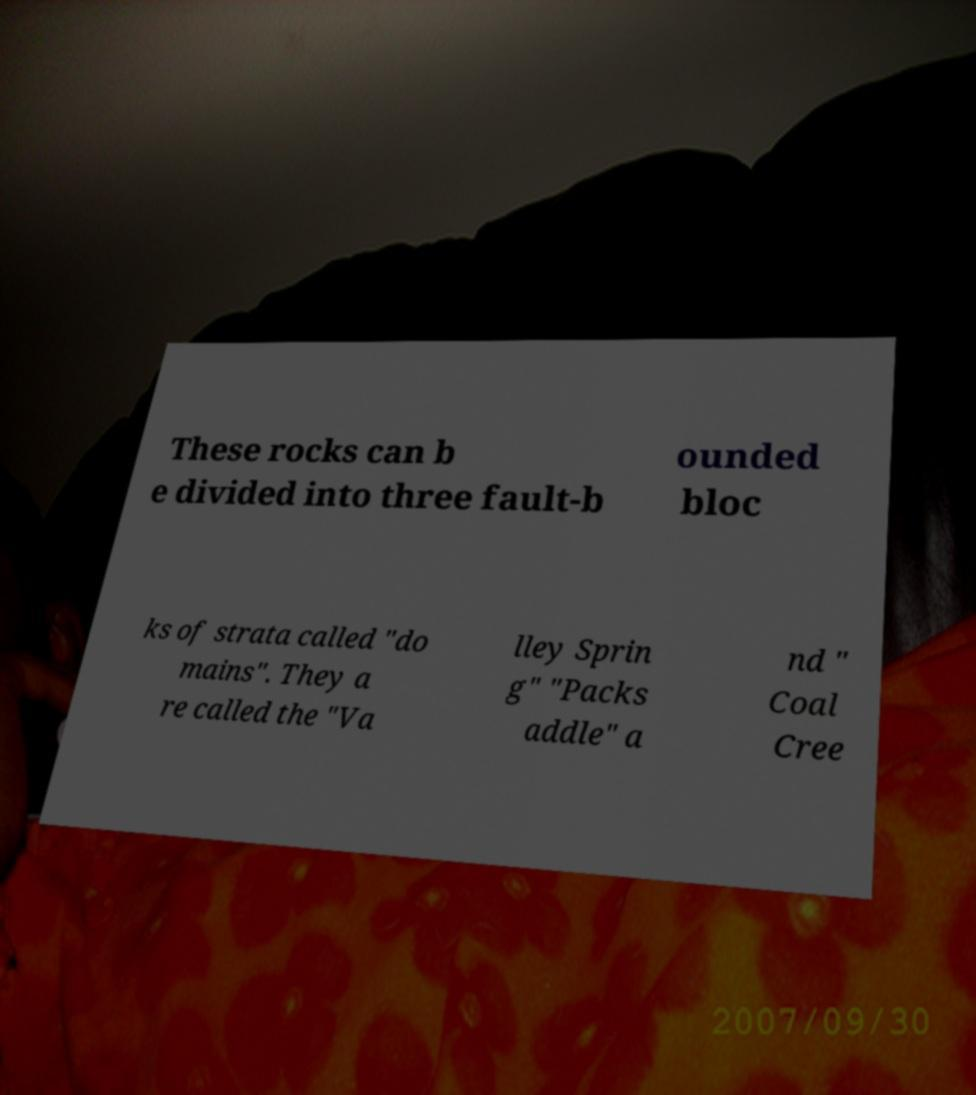Please identify and transcribe the text found in this image. These rocks can b e divided into three fault-b ounded bloc ks of strata called "do mains". They a re called the "Va lley Sprin g" "Packs addle" a nd " Coal Cree 